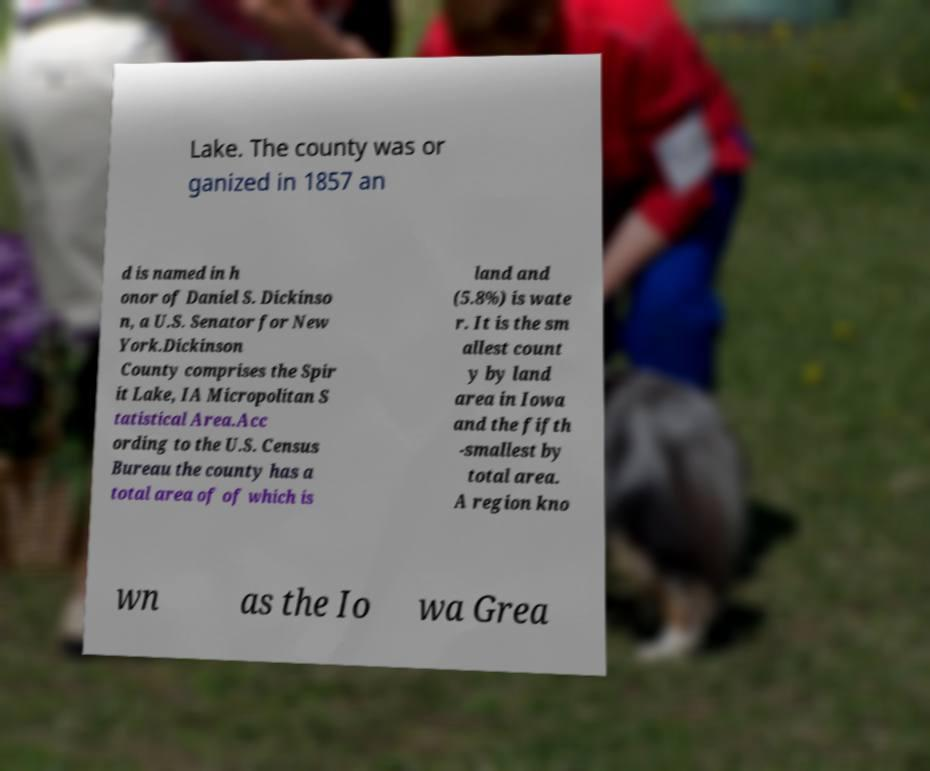Can you read and provide the text displayed in the image?This photo seems to have some interesting text. Can you extract and type it out for me? Lake. The county was or ganized in 1857 an d is named in h onor of Daniel S. Dickinso n, a U.S. Senator for New York.Dickinson County comprises the Spir it Lake, IA Micropolitan S tatistical Area.Acc ording to the U.S. Census Bureau the county has a total area of of which is land and (5.8%) is wate r. It is the sm allest count y by land area in Iowa and the fifth -smallest by total area. A region kno wn as the Io wa Grea 